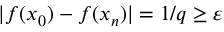<formula> <loc_0><loc_0><loc_500><loc_500>| f ( x _ { 0 } ) - f ( x _ { n } ) | = 1 / q \geq \varepsilon</formula> 